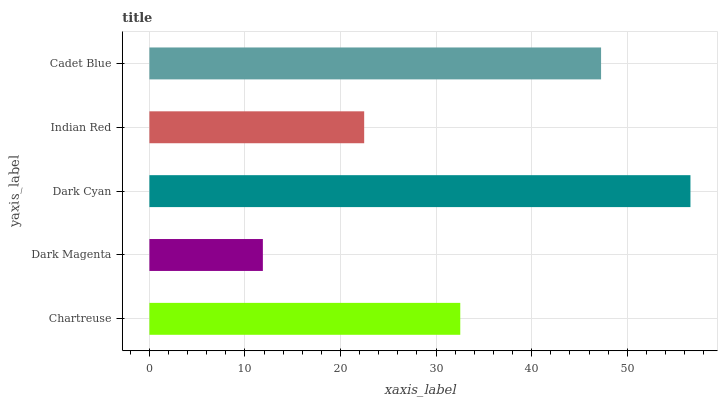Is Dark Magenta the minimum?
Answer yes or no. Yes. Is Dark Cyan the maximum?
Answer yes or no. Yes. Is Dark Cyan the minimum?
Answer yes or no. No. Is Dark Magenta the maximum?
Answer yes or no. No. Is Dark Cyan greater than Dark Magenta?
Answer yes or no. Yes. Is Dark Magenta less than Dark Cyan?
Answer yes or no. Yes. Is Dark Magenta greater than Dark Cyan?
Answer yes or no. No. Is Dark Cyan less than Dark Magenta?
Answer yes or no. No. Is Chartreuse the high median?
Answer yes or no. Yes. Is Chartreuse the low median?
Answer yes or no. Yes. Is Cadet Blue the high median?
Answer yes or no. No. Is Cadet Blue the low median?
Answer yes or no. No. 